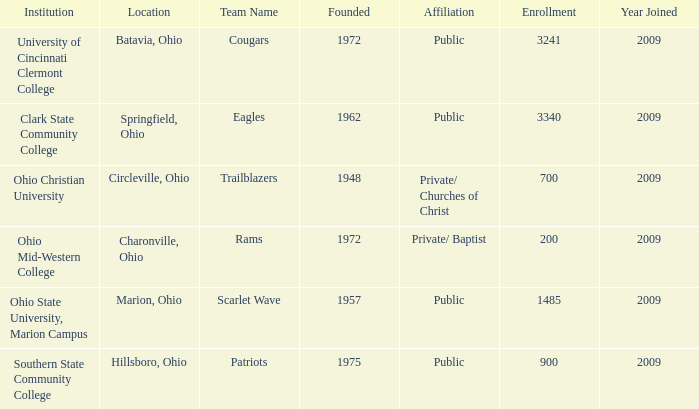What is the location when founded was 1957? Marion, Ohio. 